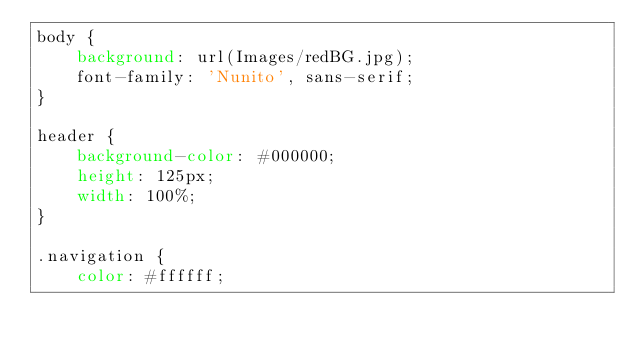<code> <loc_0><loc_0><loc_500><loc_500><_CSS_>body {
    background: url(Images/redBG.jpg);
    font-family: 'Nunito', sans-serif;
}

header {
    background-color: #000000;
    height: 125px;
    width: 100%;
}

.navigation {
    color: #ffffff;</code> 